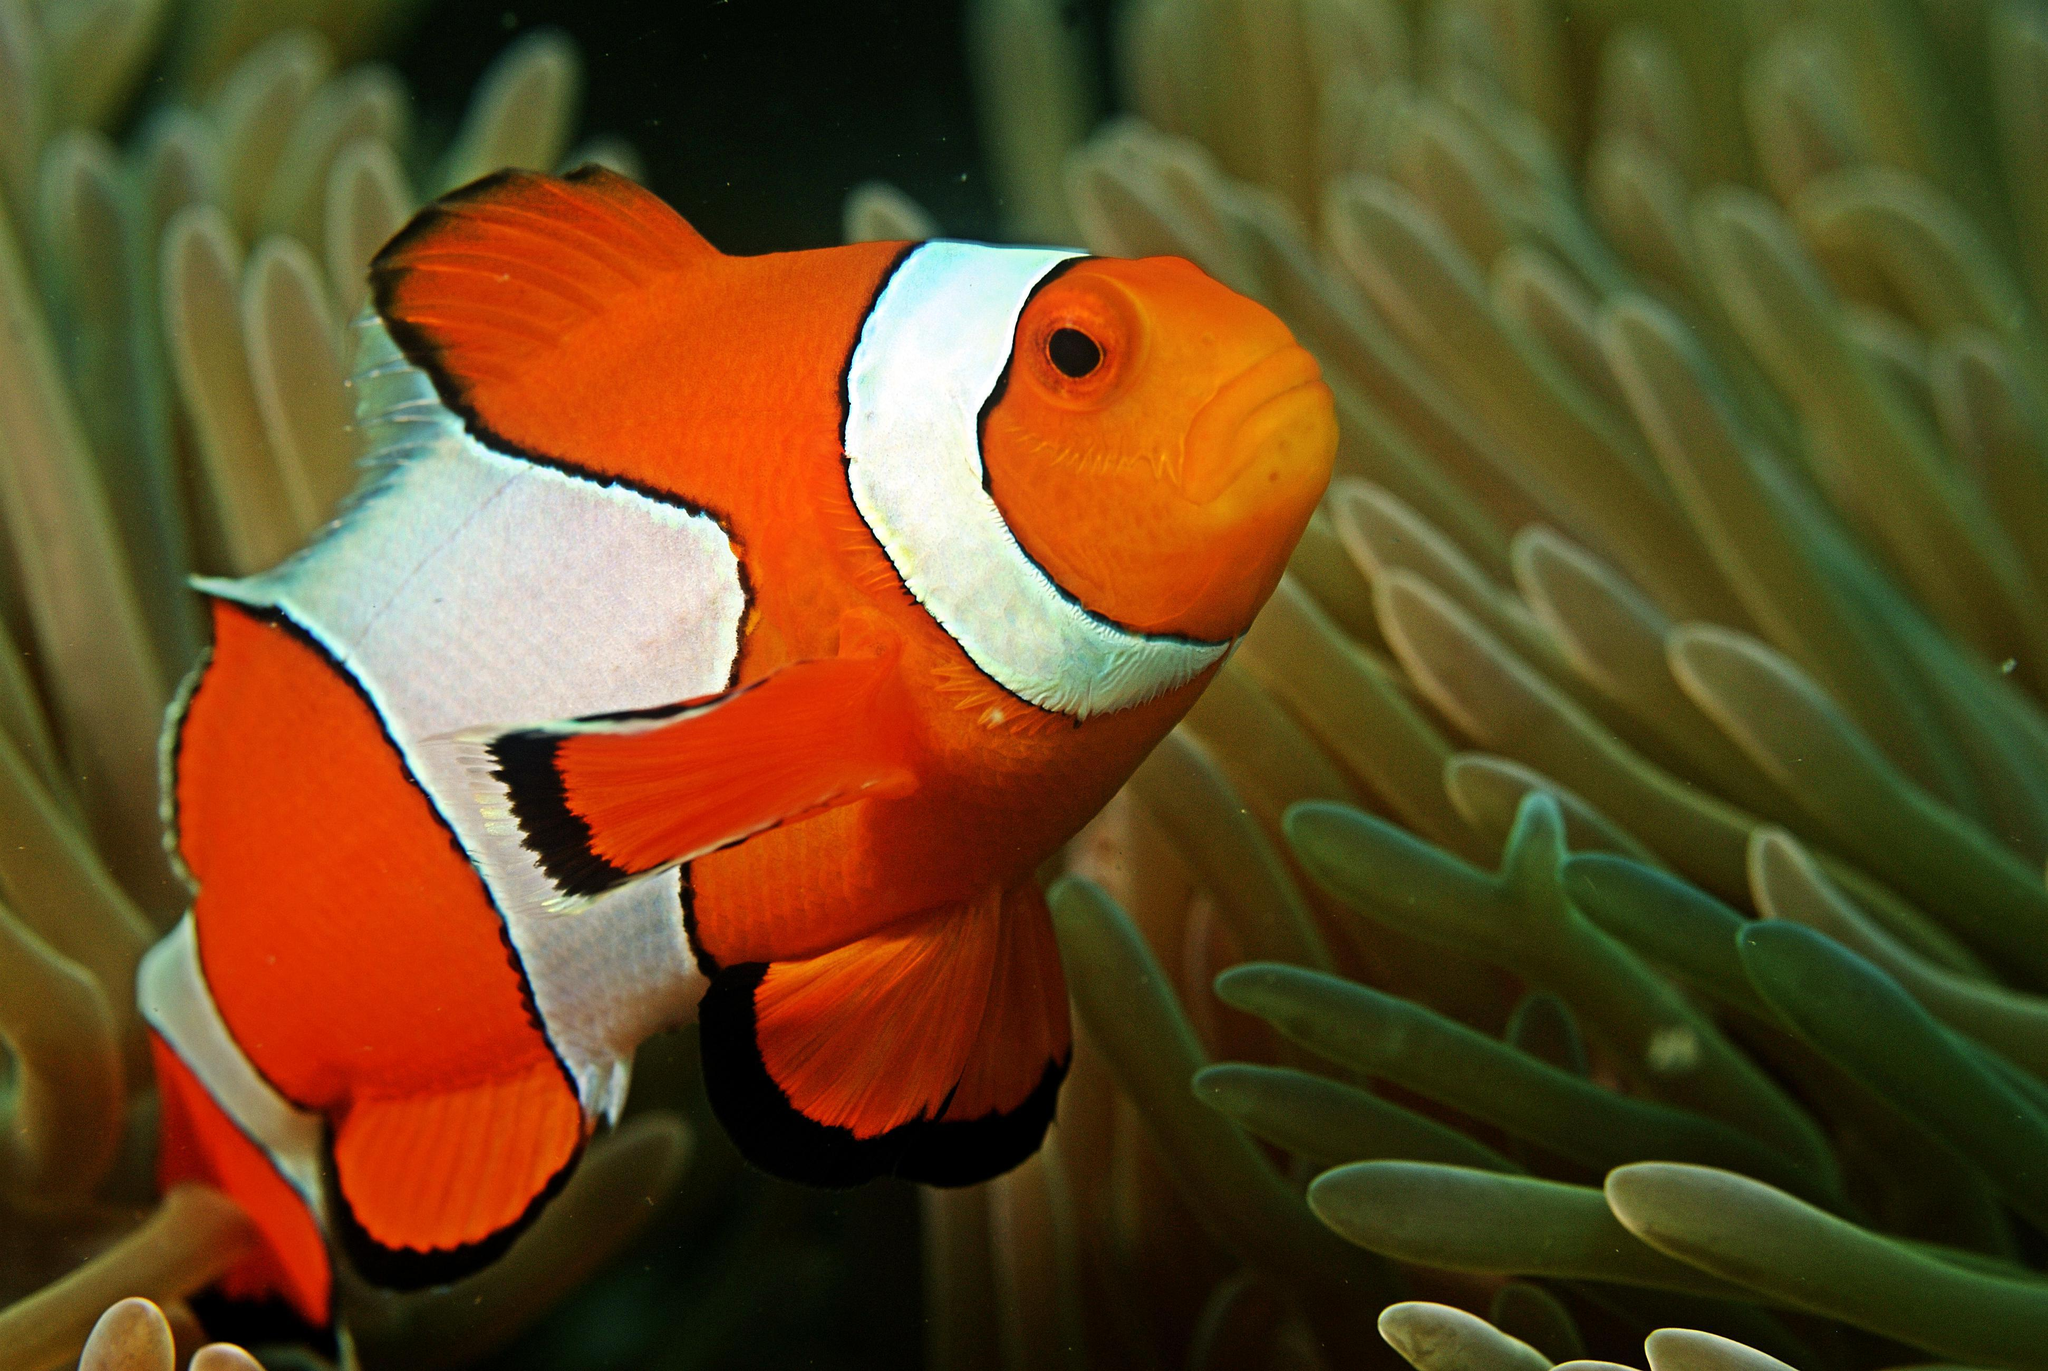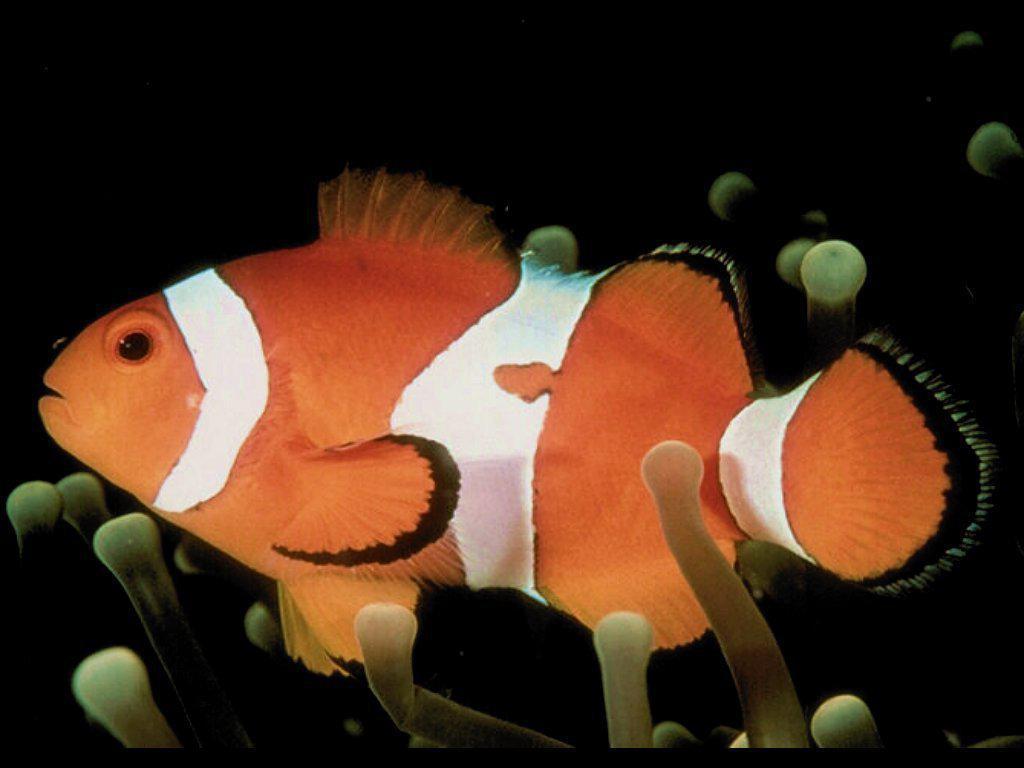The first image is the image on the left, the second image is the image on the right. For the images shown, is this caption "The clown fish in the left and right images face toward each other." true? Answer yes or no. Yes. 